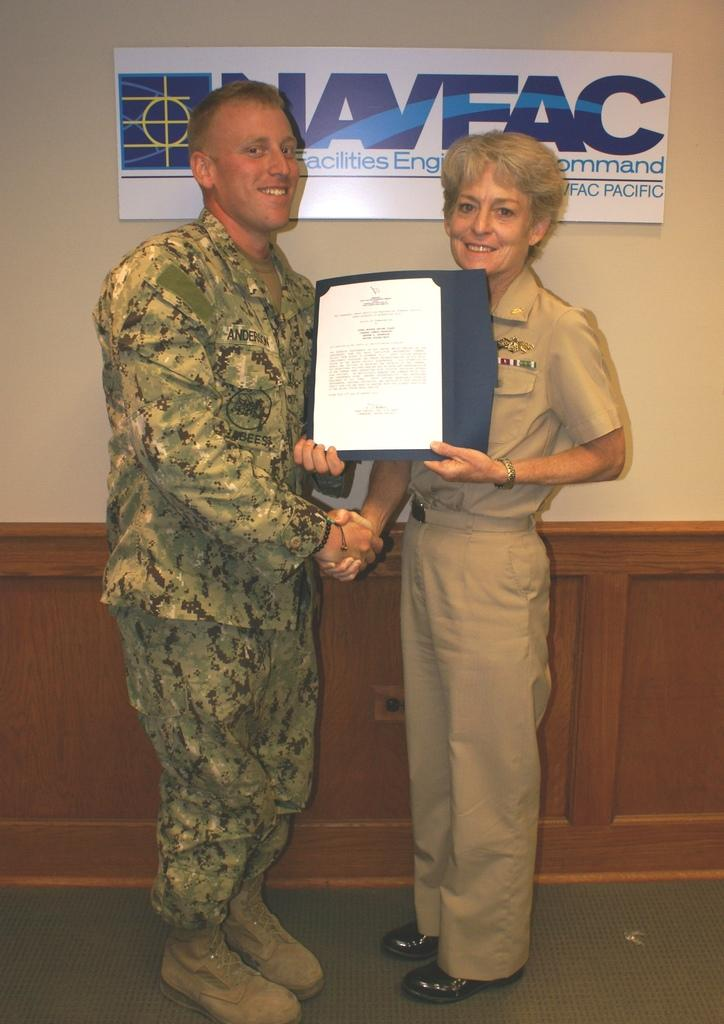<image>
Present a compact description of the photo's key features. A man with Anderson on his name tag receives an award. 